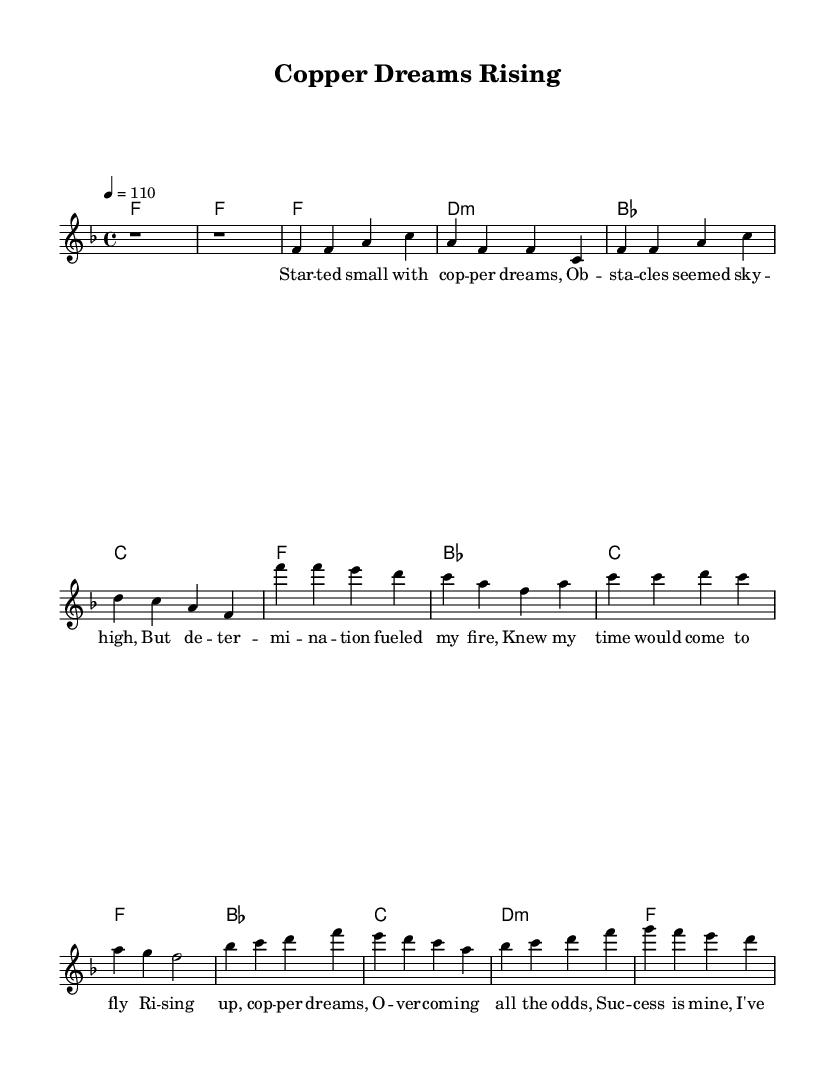What is the key signature of this music? The key signature is F major, which has one flat (B flat). This can be identified by the single flat symbol placed at the beginning of the staff.
Answer: F major What is the time signature of this music? The time signature is 4/4, indicated by the two numbers at the beginning of the score that are written in fraction form. This means there are four beats per measure, and each beat is represented by a quarter note.
Answer: 4/4 What is the tempo marking of this piece? The tempo marking is 110 beats per minute, shown as "4 = 110" which indicates the speed of the music. This means the quarter note should be played at a speed of 110 beats in one minute.
Answer: 110 How many verses are there in this song? There is one verse in this song, as indicated by the section labeled "Verse" and the lyrics that follow. There’s no additional verse section provided in the sheet music itself.
Answer: One How many lines are in the chorus? The chorus consists of four lines of lyrics, which follow the section labeled "Chorus." Each line is aligned with the melody notes above it.
Answer: Four What is the lyrical theme of this song? The lyrical theme of the song revolves around overcoming challenges and achieving success in an entrepreneurial journey, as evident from phrases in the lyrics. It emphasizes determination, rise from obstacles, and the fulfillment of dreams.
Answer: Overcoming challenges How does the bridge compare to the verse musically? The bridge features a similar melodic structure to the verse but introduces different harmonies and lyrics that reflect a transformation. This creates a contrast while still maintaining the overall soulful feel of the piece.
Answer: Different harmonies 